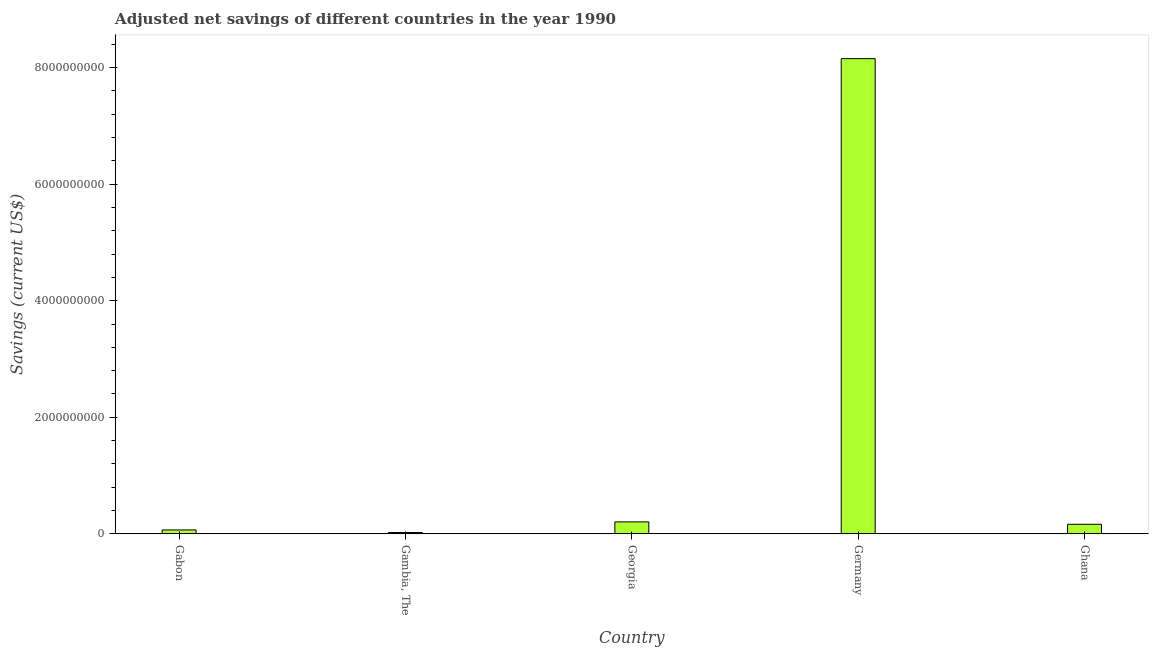Does the graph contain grids?
Ensure brevity in your answer.  No. What is the title of the graph?
Your answer should be compact. Adjusted net savings of different countries in the year 1990. What is the label or title of the Y-axis?
Offer a very short reply. Savings (current US$). What is the adjusted net savings in Gambia, The?
Make the answer very short. 2.29e+07. Across all countries, what is the maximum adjusted net savings?
Provide a succinct answer. 8.15e+09. Across all countries, what is the minimum adjusted net savings?
Provide a short and direct response. 2.29e+07. In which country was the adjusted net savings minimum?
Give a very brief answer. Gambia, The. What is the sum of the adjusted net savings?
Your response must be concise. 8.61e+09. What is the difference between the adjusted net savings in Gabon and Ghana?
Give a very brief answer. -9.69e+07. What is the average adjusted net savings per country?
Make the answer very short. 1.72e+09. What is the median adjusted net savings?
Your answer should be very brief. 1.64e+08. What is the ratio of the adjusted net savings in Gabon to that in Germany?
Provide a succinct answer. 0.01. Is the adjusted net savings in Gambia, The less than that in Ghana?
Offer a terse response. Yes. Is the difference between the adjusted net savings in Gabon and Ghana greater than the difference between any two countries?
Your answer should be compact. No. What is the difference between the highest and the second highest adjusted net savings?
Provide a succinct answer. 7.95e+09. Is the sum of the adjusted net savings in Germany and Ghana greater than the maximum adjusted net savings across all countries?
Your answer should be very brief. Yes. What is the difference between the highest and the lowest adjusted net savings?
Ensure brevity in your answer.  8.13e+09. How many bars are there?
Make the answer very short. 5. What is the Savings (current US$) in Gabon?
Give a very brief answer. 6.73e+07. What is the Savings (current US$) of Gambia, The?
Provide a short and direct response. 2.29e+07. What is the Savings (current US$) in Georgia?
Offer a very short reply. 2.06e+08. What is the Savings (current US$) of Germany?
Ensure brevity in your answer.  8.15e+09. What is the Savings (current US$) in Ghana?
Keep it short and to the point. 1.64e+08. What is the difference between the Savings (current US$) in Gabon and Gambia, The?
Make the answer very short. 4.44e+07. What is the difference between the Savings (current US$) in Gabon and Georgia?
Provide a short and direct response. -1.38e+08. What is the difference between the Savings (current US$) in Gabon and Germany?
Provide a succinct answer. -8.09e+09. What is the difference between the Savings (current US$) in Gabon and Ghana?
Give a very brief answer. -9.69e+07. What is the difference between the Savings (current US$) in Gambia, The and Georgia?
Offer a terse response. -1.83e+08. What is the difference between the Savings (current US$) in Gambia, The and Germany?
Your answer should be very brief. -8.13e+09. What is the difference between the Savings (current US$) in Gambia, The and Ghana?
Offer a terse response. -1.41e+08. What is the difference between the Savings (current US$) in Georgia and Germany?
Make the answer very short. -7.95e+09. What is the difference between the Savings (current US$) in Georgia and Ghana?
Keep it short and to the point. 4.15e+07. What is the difference between the Savings (current US$) in Germany and Ghana?
Ensure brevity in your answer.  7.99e+09. What is the ratio of the Savings (current US$) in Gabon to that in Gambia, The?
Make the answer very short. 2.94. What is the ratio of the Savings (current US$) in Gabon to that in Georgia?
Your response must be concise. 0.33. What is the ratio of the Savings (current US$) in Gabon to that in Germany?
Give a very brief answer. 0.01. What is the ratio of the Savings (current US$) in Gabon to that in Ghana?
Provide a succinct answer. 0.41. What is the ratio of the Savings (current US$) in Gambia, The to that in Georgia?
Keep it short and to the point. 0.11. What is the ratio of the Savings (current US$) in Gambia, The to that in Germany?
Your response must be concise. 0. What is the ratio of the Savings (current US$) in Gambia, The to that in Ghana?
Provide a short and direct response. 0.14. What is the ratio of the Savings (current US$) in Georgia to that in Germany?
Ensure brevity in your answer.  0.03. What is the ratio of the Savings (current US$) in Georgia to that in Ghana?
Offer a very short reply. 1.25. What is the ratio of the Savings (current US$) in Germany to that in Ghana?
Make the answer very short. 49.65. 